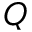<formula> <loc_0><loc_0><loc_500><loc_500>Q</formula> 